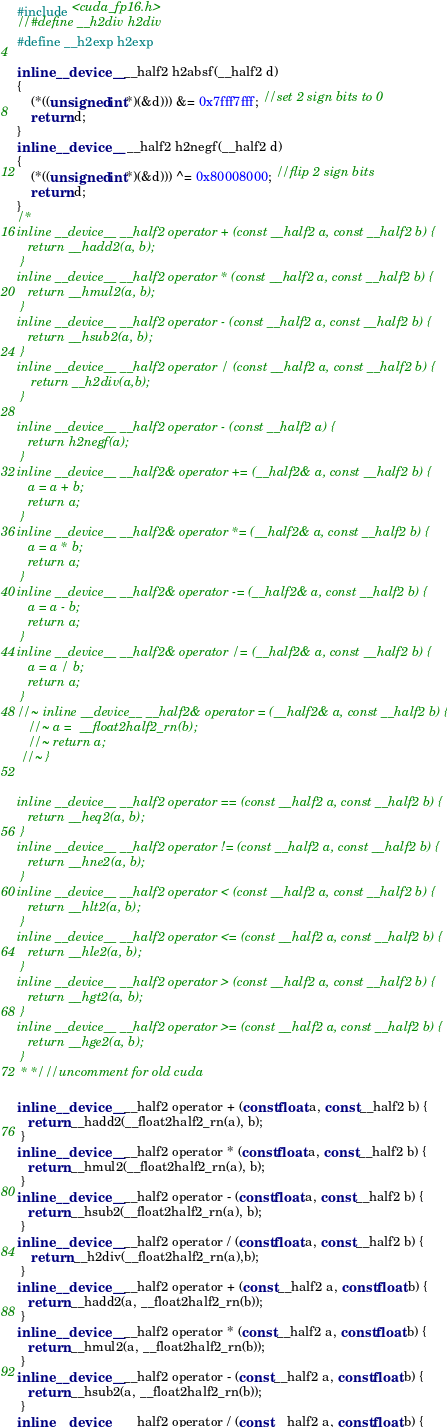<code> <loc_0><loc_0><loc_500><loc_500><_Cuda_>#include <cuda_fp16.h>
//#define __h2div h2div
#define __h2exp h2exp

inline __device__ __half2 h2absf(__half2 d)
{
	(*((unsigned int*)(&d))) &= 0x7fff7fff; //set 2 sign bits to 0
	return d;
}
inline __device__  __half2 h2negf(__half2 d)
{
	(*((unsigned int*)(&d))) ^= 0x80008000; //flip 2 sign bits
	return d;
}
/*
inline __device__ __half2 operator + (const __half2 a, const __half2 b) {
   return __hadd2(a, b);
 }
inline __device__ __half2 operator * (const __half2 a, const __half2 b) {
   return __hmul2(a, b);
 }
inline __device__ __half2 operator - (const __half2 a, const __half2 b) {
   return __hsub2(a, b);
 }
inline __device__ __half2 operator / (const __half2 a, const __half2 b) {
	return __h2div(a,b);
 }

inline __device__ __half2 operator - (const __half2 a) {
   return h2negf(a);
 }
inline __device__ __half2& operator += (__half2& a, const __half2 b) {
   a = a + b;
   return a;
 }
inline __device__ __half2& operator *= (__half2& a, const __half2 b) {
   a = a * b;
   return a;
 }
inline __device__ __half2& operator -= (__half2& a, const __half2 b) {
   a = a - b;
   return a;
 }
inline __device__ __half2& operator /= (__half2& a, const __half2 b) {
   a = a / b;
   return a;
 }
//~ inline __device__ __half2& operator = (__half2& a, const __half2 b) {
   //~ a =  __float2half2_rn(b);
   //~ return a;
 //~ }

 
inline __device__ __half2 operator == (const __half2 a, const __half2 b) {
   return __heq2(a, b);
 }
inline __device__ __half2 operator != (const __half2 a, const __half2 b) {
   return __hne2(a, b);
 }
inline __device__ __half2 operator < (const __half2 a, const __half2 b) {
   return __hlt2(a, b);
 }
inline __device__ __half2 operator <= (const __half2 a, const __half2 b) {
   return __hle2(a, b);
 }
inline __device__ __half2 operator > (const __half2 a, const __half2 b) {
   return __hgt2(a, b);
 }
inline __device__ __half2 operator >= (const __half2 a, const __half2 b) {
   return __hge2(a, b);
 }
 * */ //uncomment for old cuda

inline __device__ __half2 operator + (const float a, const __half2 b) {
   return __hadd2(__float2half2_rn(a), b);
 }
inline __device__ __half2 operator * (const float a, const __half2 b) {
   return __hmul2(__float2half2_rn(a), b);
 }
inline __device__ __half2 operator - (const float a, const __half2 b) {
   return __hsub2(__float2half2_rn(a), b);
 }
inline __device__ __half2 operator / (const float a, const __half2 b) {
	return __h2div(__float2half2_rn(a),b);
 }
inline __device__ __half2 operator + (const __half2 a, const float b) {
   return __hadd2(a, __float2half2_rn(b));
 }
inline __device__ __half2 operator * (const __half2 a, const float b) {
   return __hmul2(a, __float2half2_rn(b));
 }
inline __device__ __half2 operator - (const __half2 a, const float b) {
   return __hsub2(a, __float2half2_rn(b));
 }
inline __device__ __half2 operator / (const __half2 a, const float b) {</code> 